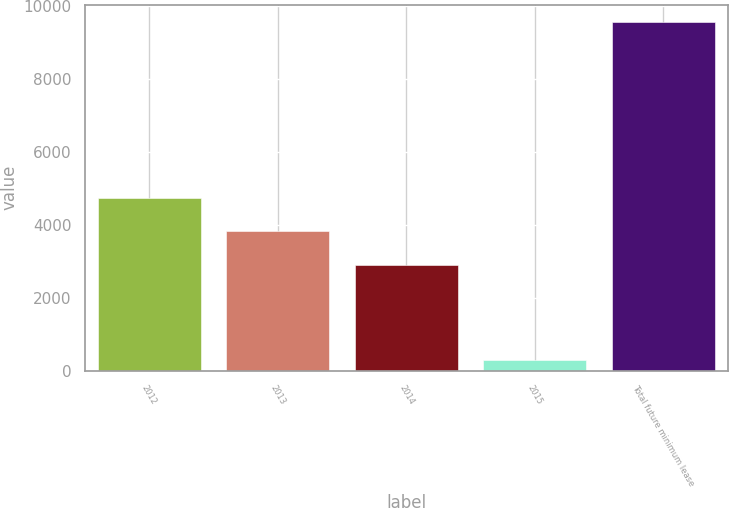<chart> <loc_0><loc_0><loc_500><loc_500><bar_chart><fcel>2012<fcel>2013<fcel>2014<fcel>2015<fcel>Total future minimum lease<nl><fcel>4744.6<fcel>3816.8<fcel>2889<fcel>285<fcel>9563<nl></chart> 